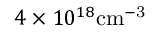Convert formula to latex. <formula><loc_0><loc_0><loc_500><loc_500>4 \times 1 0 ^ { 1 8 } c m ^ { - 3 }</formula> 